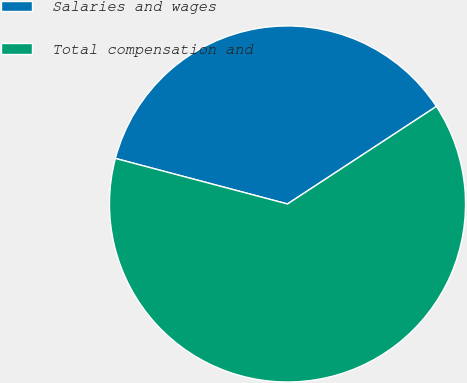<chart> <loc_0><loc_0><loc_500><loc_500><pie_chart><fcel>Salaries and wages<fcel>Total compensation and<nl><fcel>36.65%<fcel>63.35%<nl></chart> 